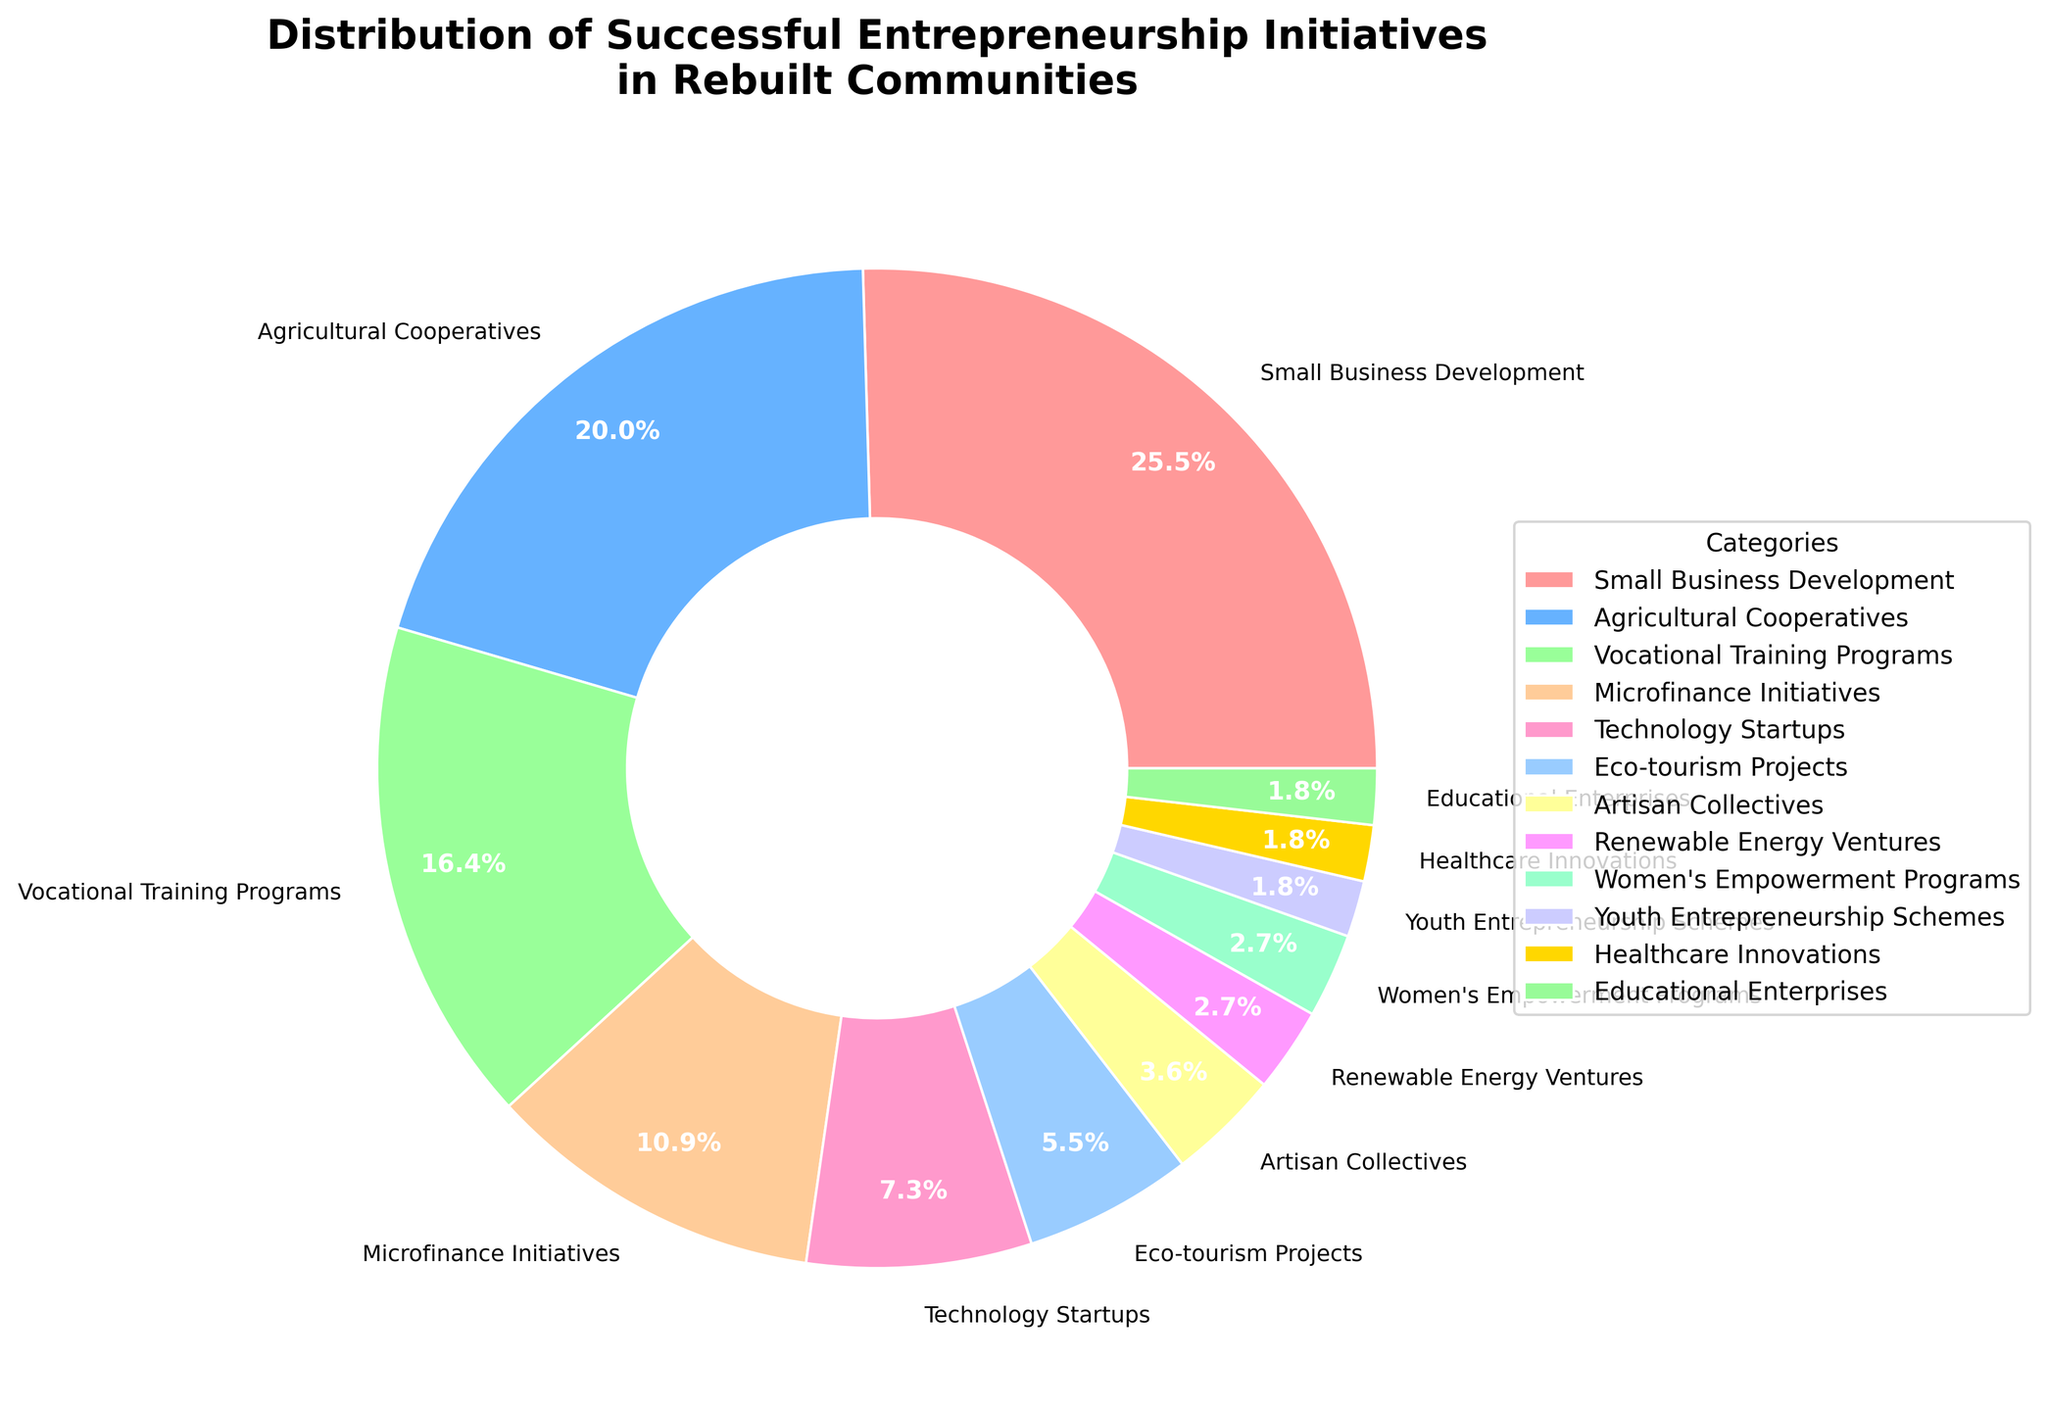what is the largest category in the pie chart? The pie chart displays the different entrepreneurial initiatives and their respective percentages. The largest category is the one with the highest percentage.
Answer: Small Business Development which category has the second highest percentage? According to the pie chart, the category with the second highest percentage follows the largest one. The largest is Small Business Development at 28%, and the next is Agricultural Cooperatives.
Answer: Agricultural Cooperatives how many categories have a percentage less than 5%? By observing the pie chart, count the slices that have a percentage display lower than 5%. These are Artisan Collectives (4%), Renewable Energy Ventures (3%), Women's Empowerment Programs (3%), Youth Entrepreneurship Schemes (2%), Healthcare Innovations (2%), and Educational Enterprises (2%). There are 6 categories.
Answer: 6 what is the total percentage of categories focused on technology and energy? Summing the percentages of Technology Startups and Renewable Energy Ventures, we get 8% + 3% = 11%.
Answer: 11% which categories have an equal percentage distribution? The pie chart shows specific percentages for each category. By comparing the percentages, categories with the same percentages are Renewable Energy Ventures, Women's Empowerment Programs, Youth Entrepreneurship Schemes, Healthcare Innovations, and Educational Enterprises, all having 2%.
Answer: Renewable Energy Ventures, Women's Empowerment Programs, Youth Entrepreneurship Schemes, Healthcare Innovations, Educational Enterprises 